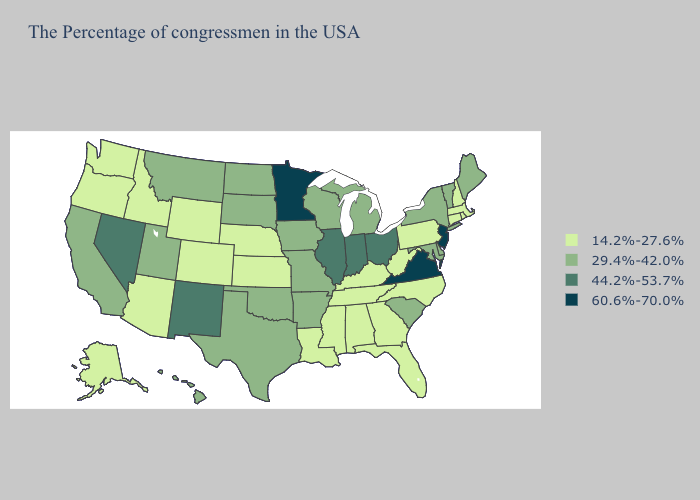Does Illinois have the lowest value in the USA?
Keep it brief. No. Does Montana have the lowest value in the West?
Concise answer only. No. What is the highest value in states that border California?
Write a very short answer. 44.2%-53.7%. Does Wyoming have the highest value in the West?
Write a very short answer. No. What is the highest value in states that border Vermont?
Keep it brief. 29.4%-42.0%. What is the highest value in the USA?
Quick response, please. 60.6%-70.0%. Which states hav the highest value in the MidWest?
Quick response, please. Minnesota. Name the states that have a value in the range 60.6%-70.0%?
Give a very brief answer. New Jersey, Virginia, Minnesota. Among the states that border Texas , does New Mexico have the highest value?
Quick response, please. Yes. How many symbols are there in the legend?
Give a very brief answer. 4. Does Missouri have the highest value in the MidWest?
Keep it brief. No. What is the highest value in states that border Idaho?
Be succinct. 44.2%-53.7%. Does Vermont have the lowest value in the Northeast?
Be succinct. No. 